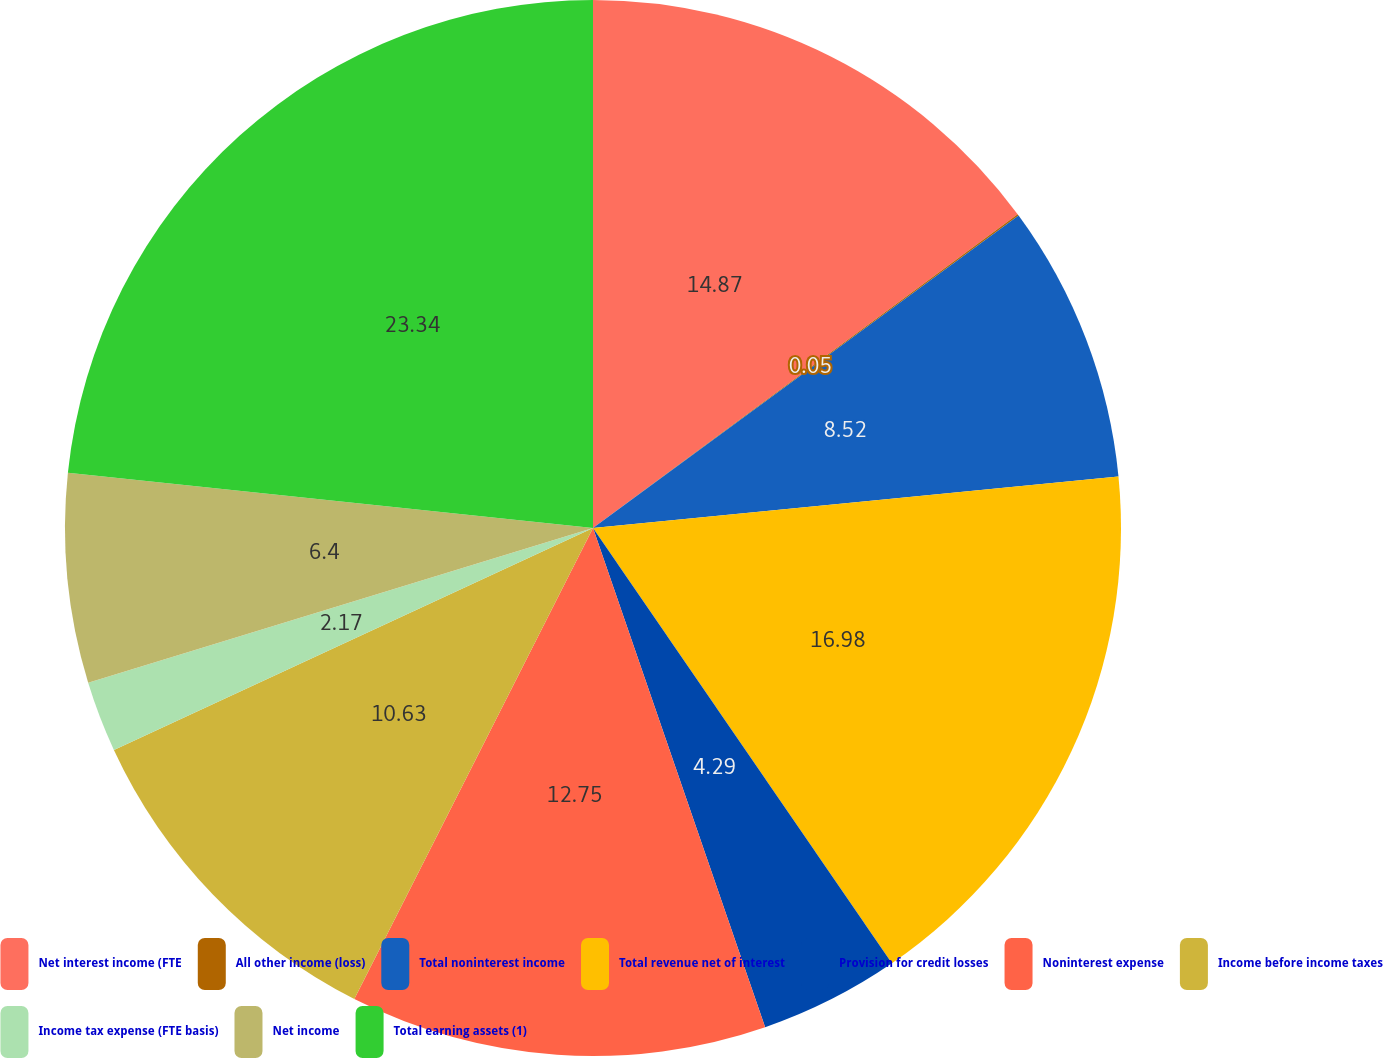Convert chart. <chart><loc_0><loc_0><loc_500><loc_500><pie_chart><fcel>Net interest income (FTE<fcel>All other income (loss)<fcel>Total noninterest income<fcel>Total revenue net of interest<fcel>Provision for credit losses<fcel>Noninterest expense<fcel>Income before income taxes<fcel>Income tax expense (FTE basis)<fcel>Net income<fcel>Total earning assets (1)<nl><fcel>14.87%<fcel>0.05%<fcel>8.52%<fcel>16.98%<fcel>4.29%<fcel>12.75%<fcel>10.63%<fcel>2.17%<fcel>6.4%<fcel>23.33%<nl></chart> 